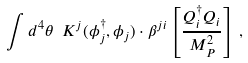<formula> <loc_0><loc_0><loc_500><loc_500>\int d ^ { 4 } \theta \ K ^ { j } ( \phi _ { j } ^ { \dagger } , \phi _ { j } ) \cdot \beta ^ { j i } \left [ \frac { Q _ { i } ^ { \dagger } Q _ { i } } { M _ { P } ^ { 2 } } \right ] \, ,</formula> 